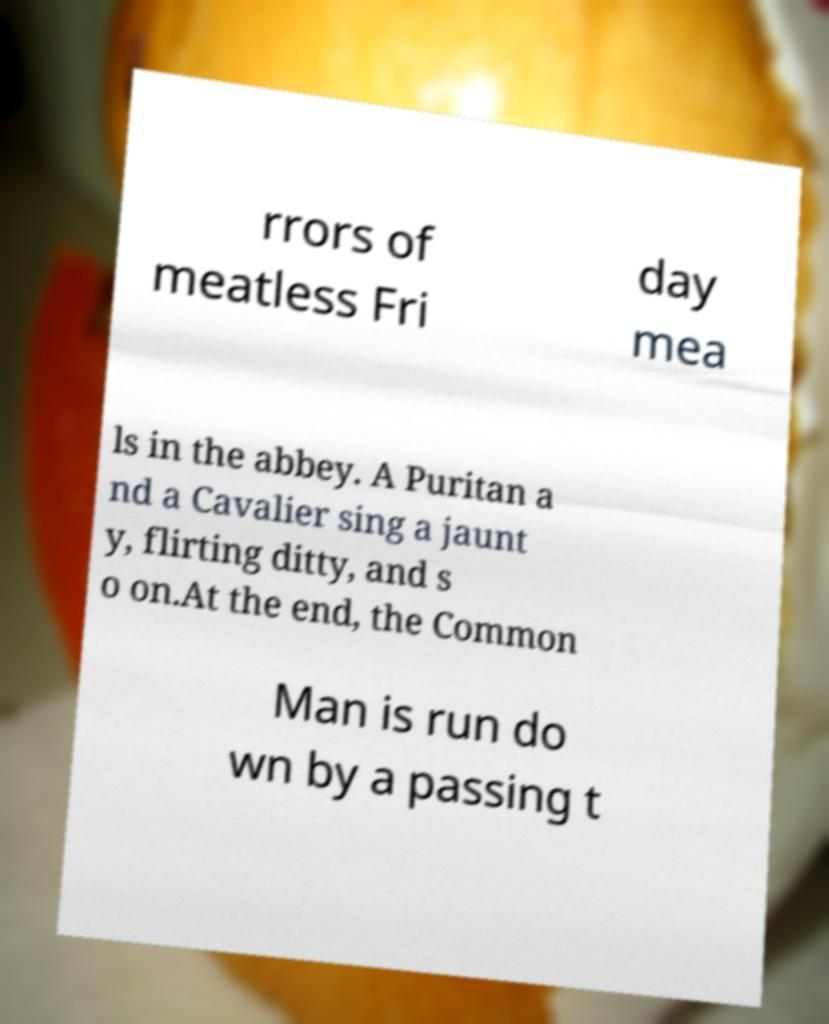There's text embedded in this image that I need extracted. Can you transcribe it verbatim? rrors of meatless Fri day mea ls in the abbey. A Puritan a nd a Cavalier sing a jaunt y, flirting ditty, and s o on.At the end, the Common Man is run do wn by a passing t 